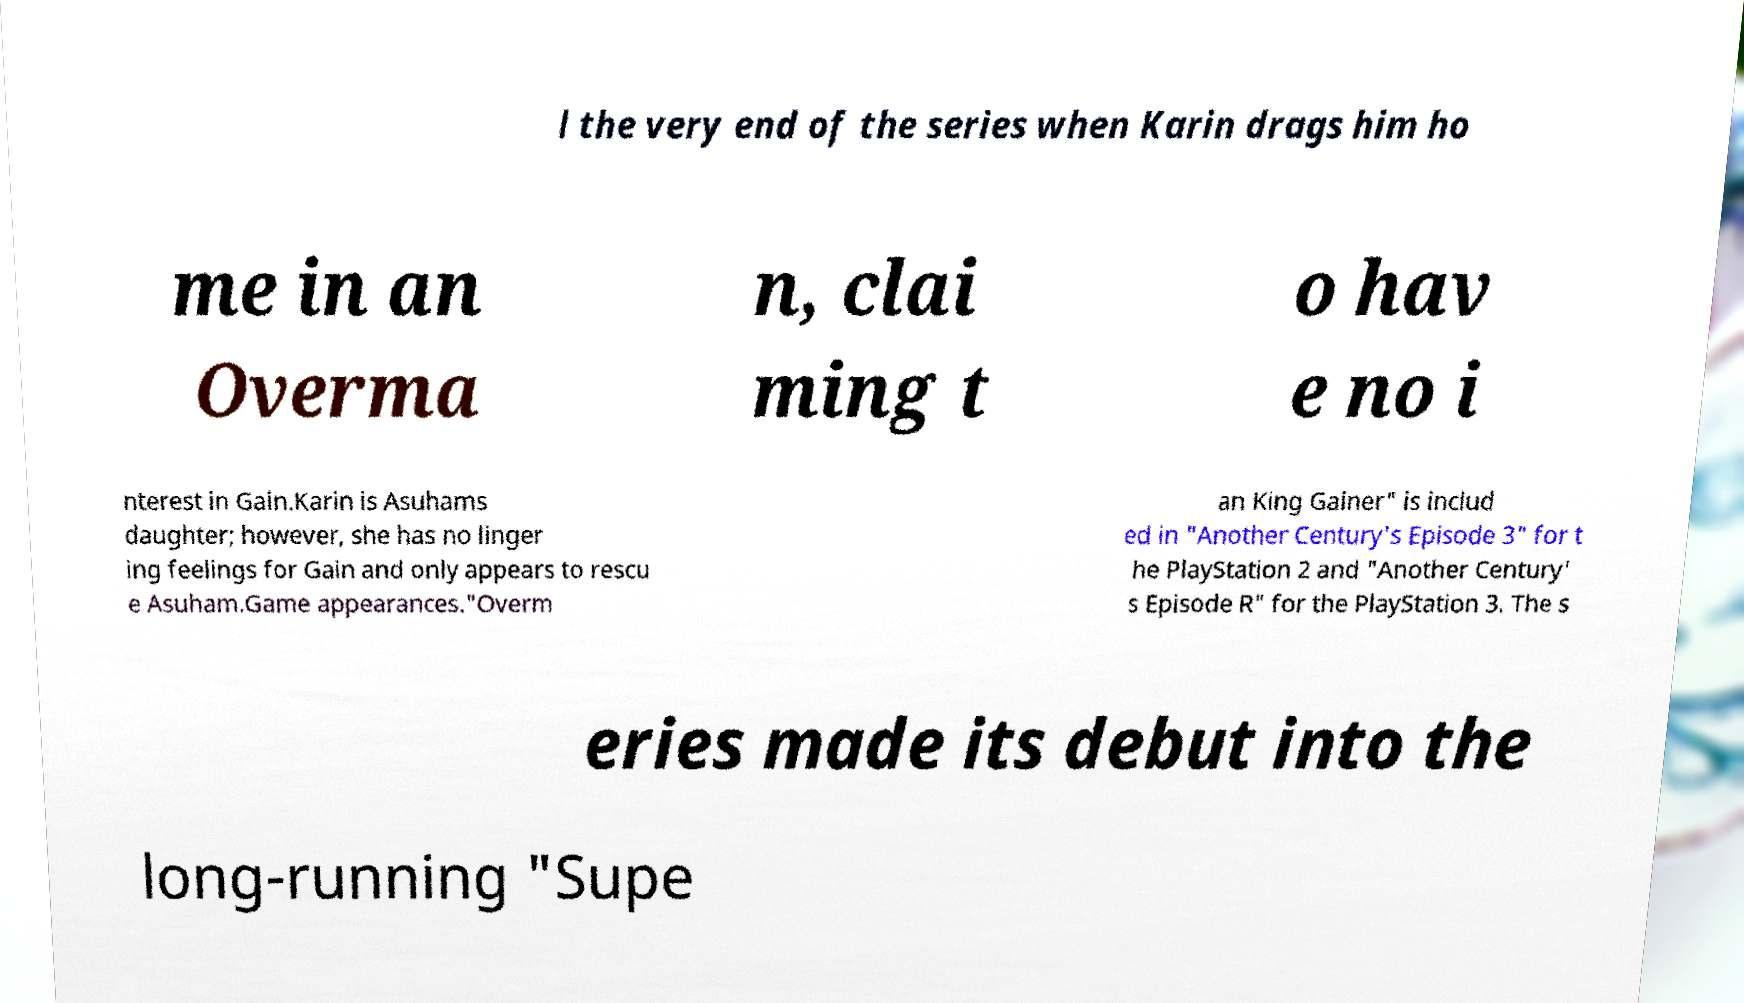Could you assist in decoding the text presented in this image and type it out clearly? l the very end of the series when Karin drags him ho me in an Overma n, clai ming t o hav e no i nterest in Gain.Karin is Asuhams daughter; however, she has no linger ing feelings for Gain and only appears to rescu e Asuham.Game appearances."Overm an King Gainer" is includ ed in "Another Century's Episode 3" for t he PlayStation 2 and "Another Century' s Episode R" for the PlayStation 3. The s eries made its debut into the long-running "Supe 